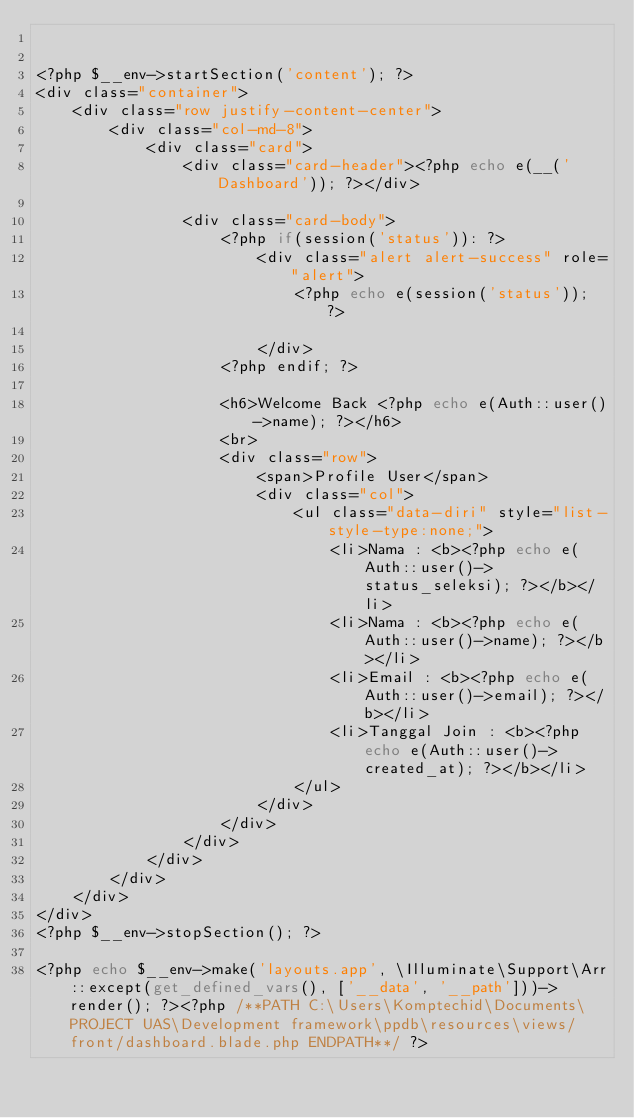Convert code to text. <code><loc_0><loc_0><loc_500><loc_500><_PHP_>

<?php $__env->startSection('content'); ?>
<div class="container">
    <div class="row justify-content-center">
        <div class="col-md-8">
            <div class="card">
                <div class="card-header"><?php echo e(__('Dashboard')); ?></div>

                <div class="card-body">
                    <?php if(session('status')): ?>
                        <div class="alert alert-success" role="alert">
                            <?php echo e(session('status')); ?>

                        </div>
                    <?php endif; ?>

                    <h6>Welcome Back <?php echo e(Auth::user()->name); ?></h6>
                    <br>
                    <div class="row">
                        <span>Profile User</span>
                        <div class="col">
                            <ul class="data-diri" style="list-style-type:none;">
                                <li>Nama : <b><?php echo e(Auth::user()->status_seleksi); ?></b></li>
                                <li>Nama : <b><?php echo e(Auth::user()->name); ?></b></li>
                                <li>Email : <b><?php echo e(Auth::user()->email); ?></b></li>
                                <li>Tanggal Join : <b><?php echo e(Auth::user()->created_at); ?></b></li>
                            </ul>
                        </div>
                    </div>
                </div>
            </div>
        </div>
    </div>
</div>
<?php $__env->stopSection(); ?>

<?php echo $__env->make('layouts.app', \Illuminate\Support\Arr::except(get_defined_vars(), ['__data', '__path']))->render(); ?><?php /**PATH C:\Users\Komptechid\Documents\PROJECT UAS\Development framework\ppdb\resources\views/front/dashboard.blade.php ENDPATH**/ ?></code> 